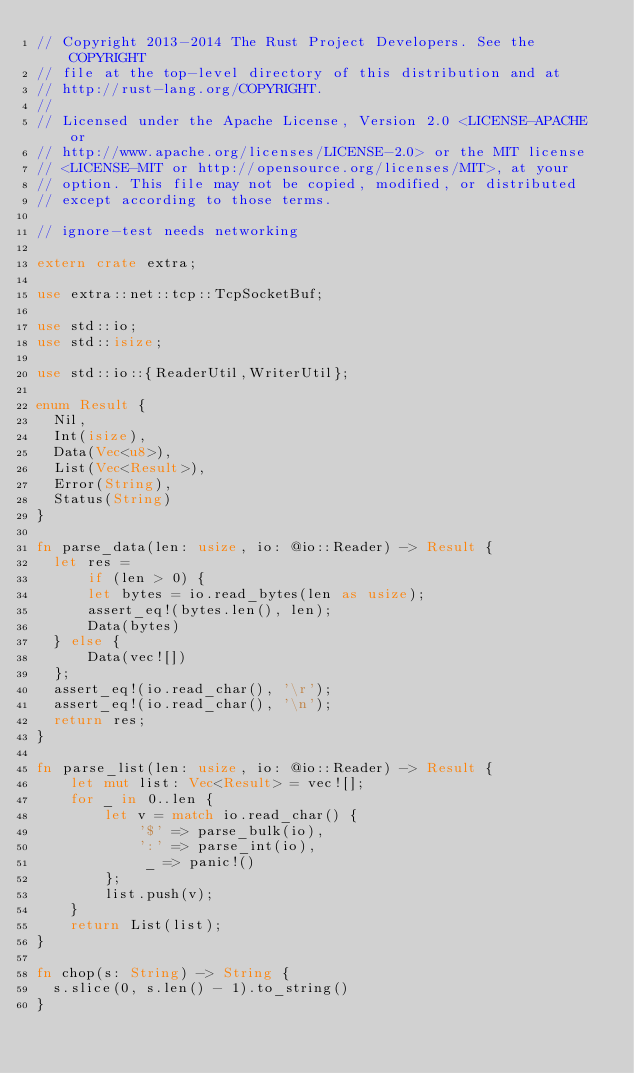<code> <loc_0><loc_0><loc_500><loc_500><_Rust_>// Copyright 2013-2014 The Rust Project Developers. See the COPYRIGHT
// file at the top-level directory of this distribution and at
// http://rust-lang.org/COPYRIGHT.
//
// Licensed under the Apache License, Version 2.0 <LICENSE-APACHE or
// http://www.apache.org/licenses/LICENSE-2.0> or the MIT license
// <LICENSE-MIT or http://opensource.org/licenses/MIT>, at your
// option. This file may not be copied, modified, or distributed
// except according to those terms.

// ignore-test needs networking

extern crate extra;

use extra::net::tcp::TcpSocketBuf;

use std::io;
use std::isize;

use std::io::{ReaderUtil,WriterUtil};

enum Result {
  Nil,
  Int(isize),
  Data(Vec<u8>),
  List(Vec<Result>),
  Error(String),
  Status(String)
}

fn parse_data(len: usize, io: @io::Reader) -> Result {
  let res =
      if (len > 0) {
      let bytes = io.read_bytes(len as usize);
      assert_eq!(bytes.len(), len);
      Data(bytes)
  } else {
      Data(vec![])
  };
  assert_eq!(io.read_char(), '\r');
  assert_eq!(io.read_char(), '\n');
  return res;
}

fn parse_list(len: usize, io: @io::Reader) -> Result {
    let mut list: Vec<Result> = vec![];
    for _ in 0..len {
        let v = match io.read_char() {
            '$' => parse_bulk(io),
            ':' => parse_int(io),
             _ => panic!()
        };
        list.push(v);
    }
    return List(list);
}

fn chop(s: String) -> String {
  s.slice(0, s.len() - 1).to_string()
}
</code> 